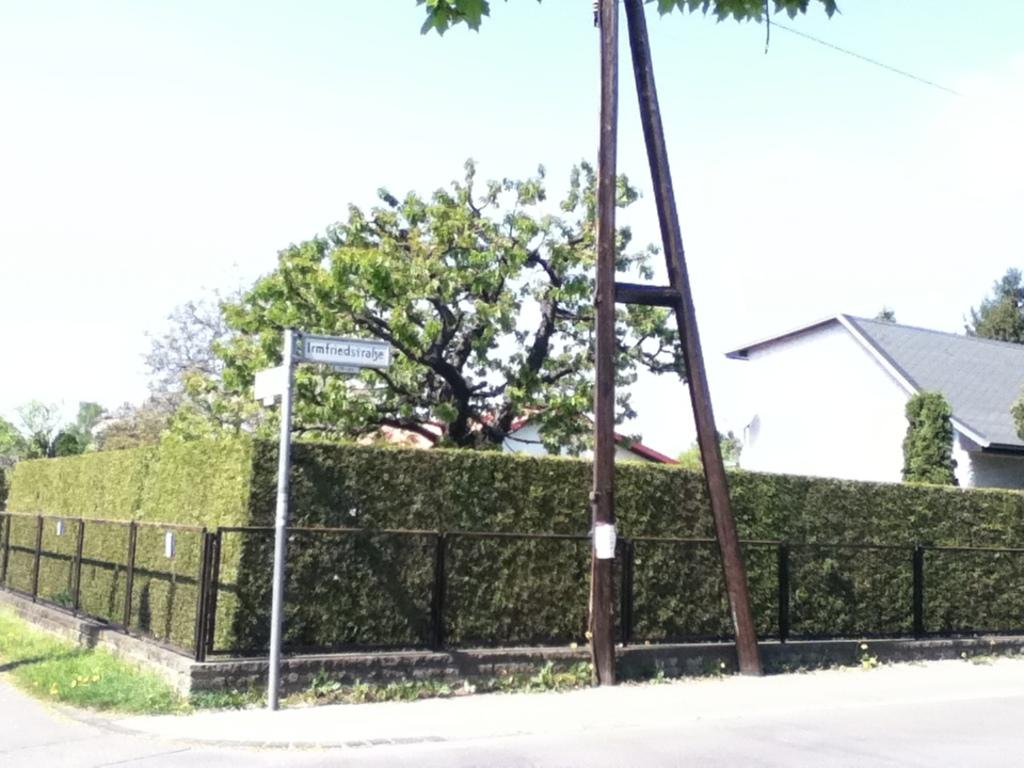What type of structure is visible in the image? There is a house in the image. What type of vegetation can be seen in the image? There are plants, trees, and grass visible in the image. What is used to enclose the grass area in the image? There is a fencing around the grass floor in the image. What type of copper waste can be seen in the image? There is no copper waste present in the image. 